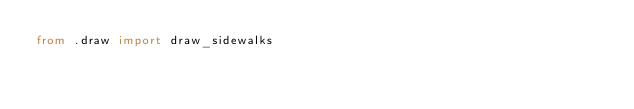<code> <loc_0><loc_0><loc_500><loc_500><_Python_>from .draw import draw_sidewalks
</code> 